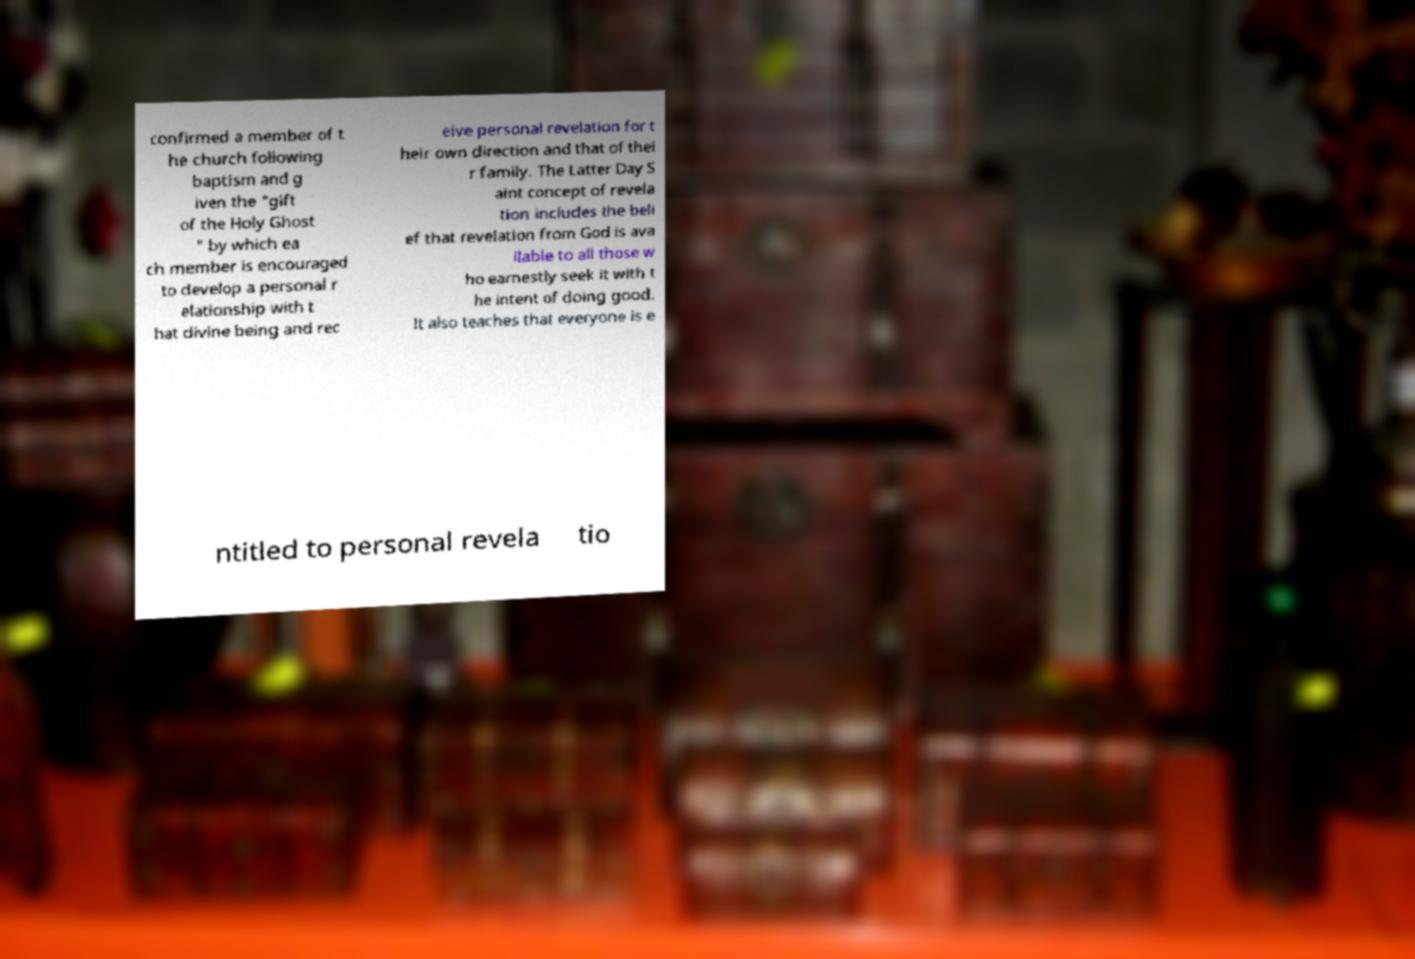Please read and relay the text visible in this image. What does it say? confirmed a member of t he church following baptism and g iven the "gift of the Holy Ghost " by which ea ch member is encouraged to develop a personal r elationship with t hat divine being and rec eive personal revelation for t heir own direction and that of thei r family. The Latter Day S aint concept of revela tion includes the beli ef that revelation from God is ava ilable to all those w ho earnestly seek it with t he intent of doing good. It also teaches that everyone is e ntitled to personal revela tio 